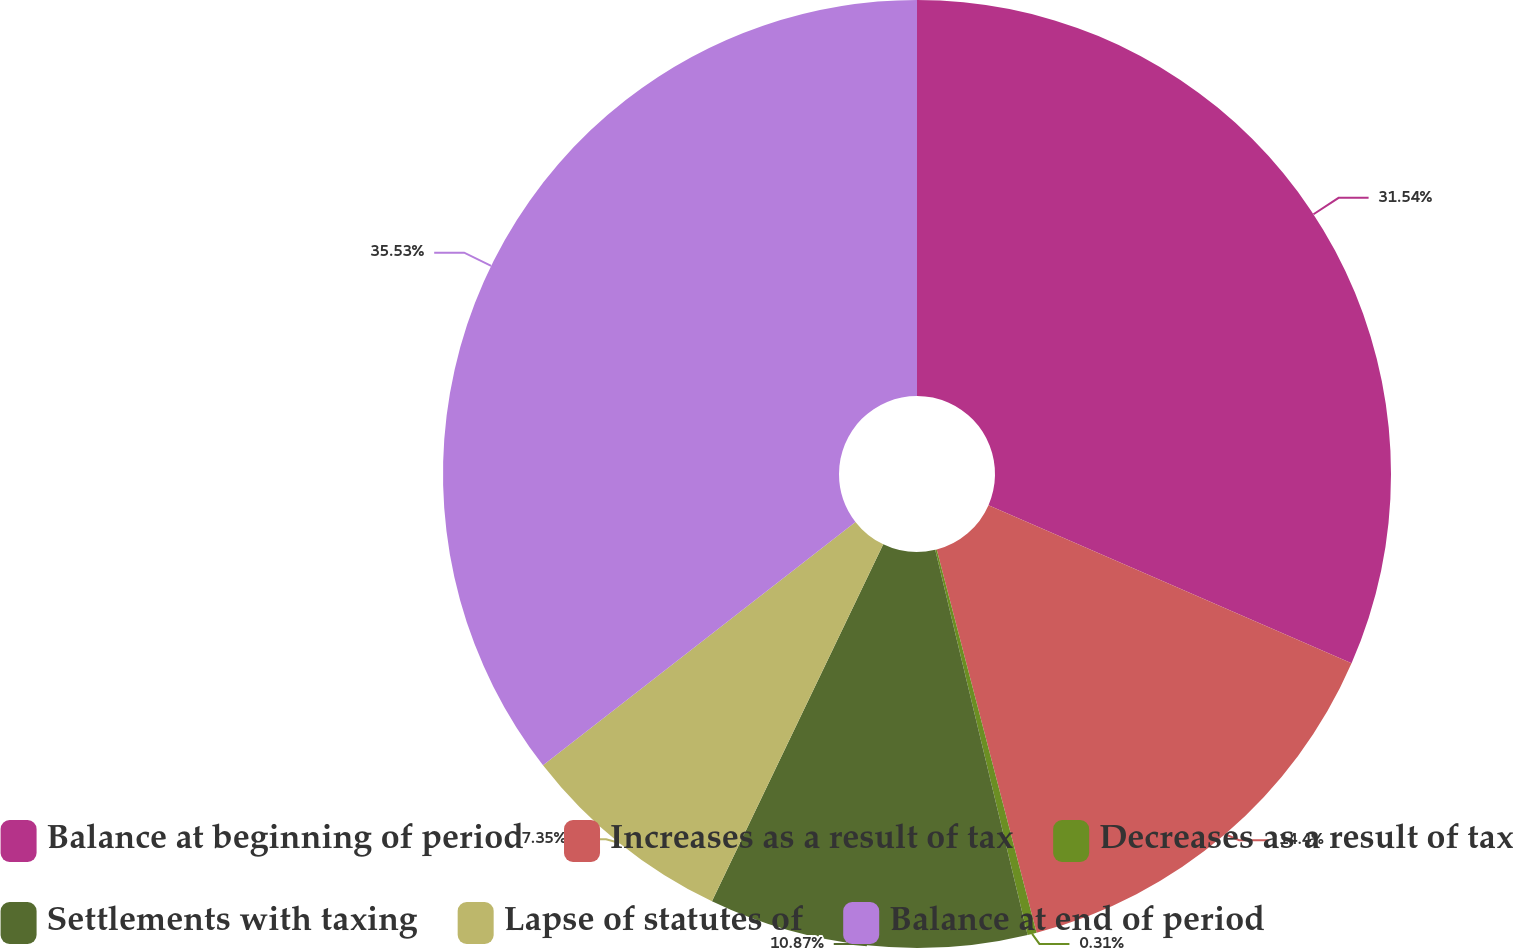Convert chart. <chart><loc_0><loc_0><loc_500><loc_500><pie_chart><fcel>Balance at beginning of period<fcel>Increases as a result of tax<fcel>Decreases as a result of tax<fcel>Settlements with taxing<fcel>Lapse of statutes of<fcel>Balance at end of period<nl><fcel>31.54%<fcel>14.4%<fcel>0.31%<fcel>10.87%<fcel>7.35%<fcel>35.53%<nl></chart> 